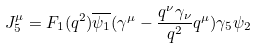Convert formula to latex. <formula><loc_0><loc_0><loc_500><loc_500>J _ { 5 } ^ { \mu } = F _ { 1 } ( q ^ { 2 } ) \overline { \psi _ { 1 } } ( \gamma ^ { \mu } - \frac { q ^ { \nu } \gamma _ { \nu } } { q ^ { 2 } } q ^ { \mu } ) \gamma _ { 5 } \psi _ { 2 }</formula> 